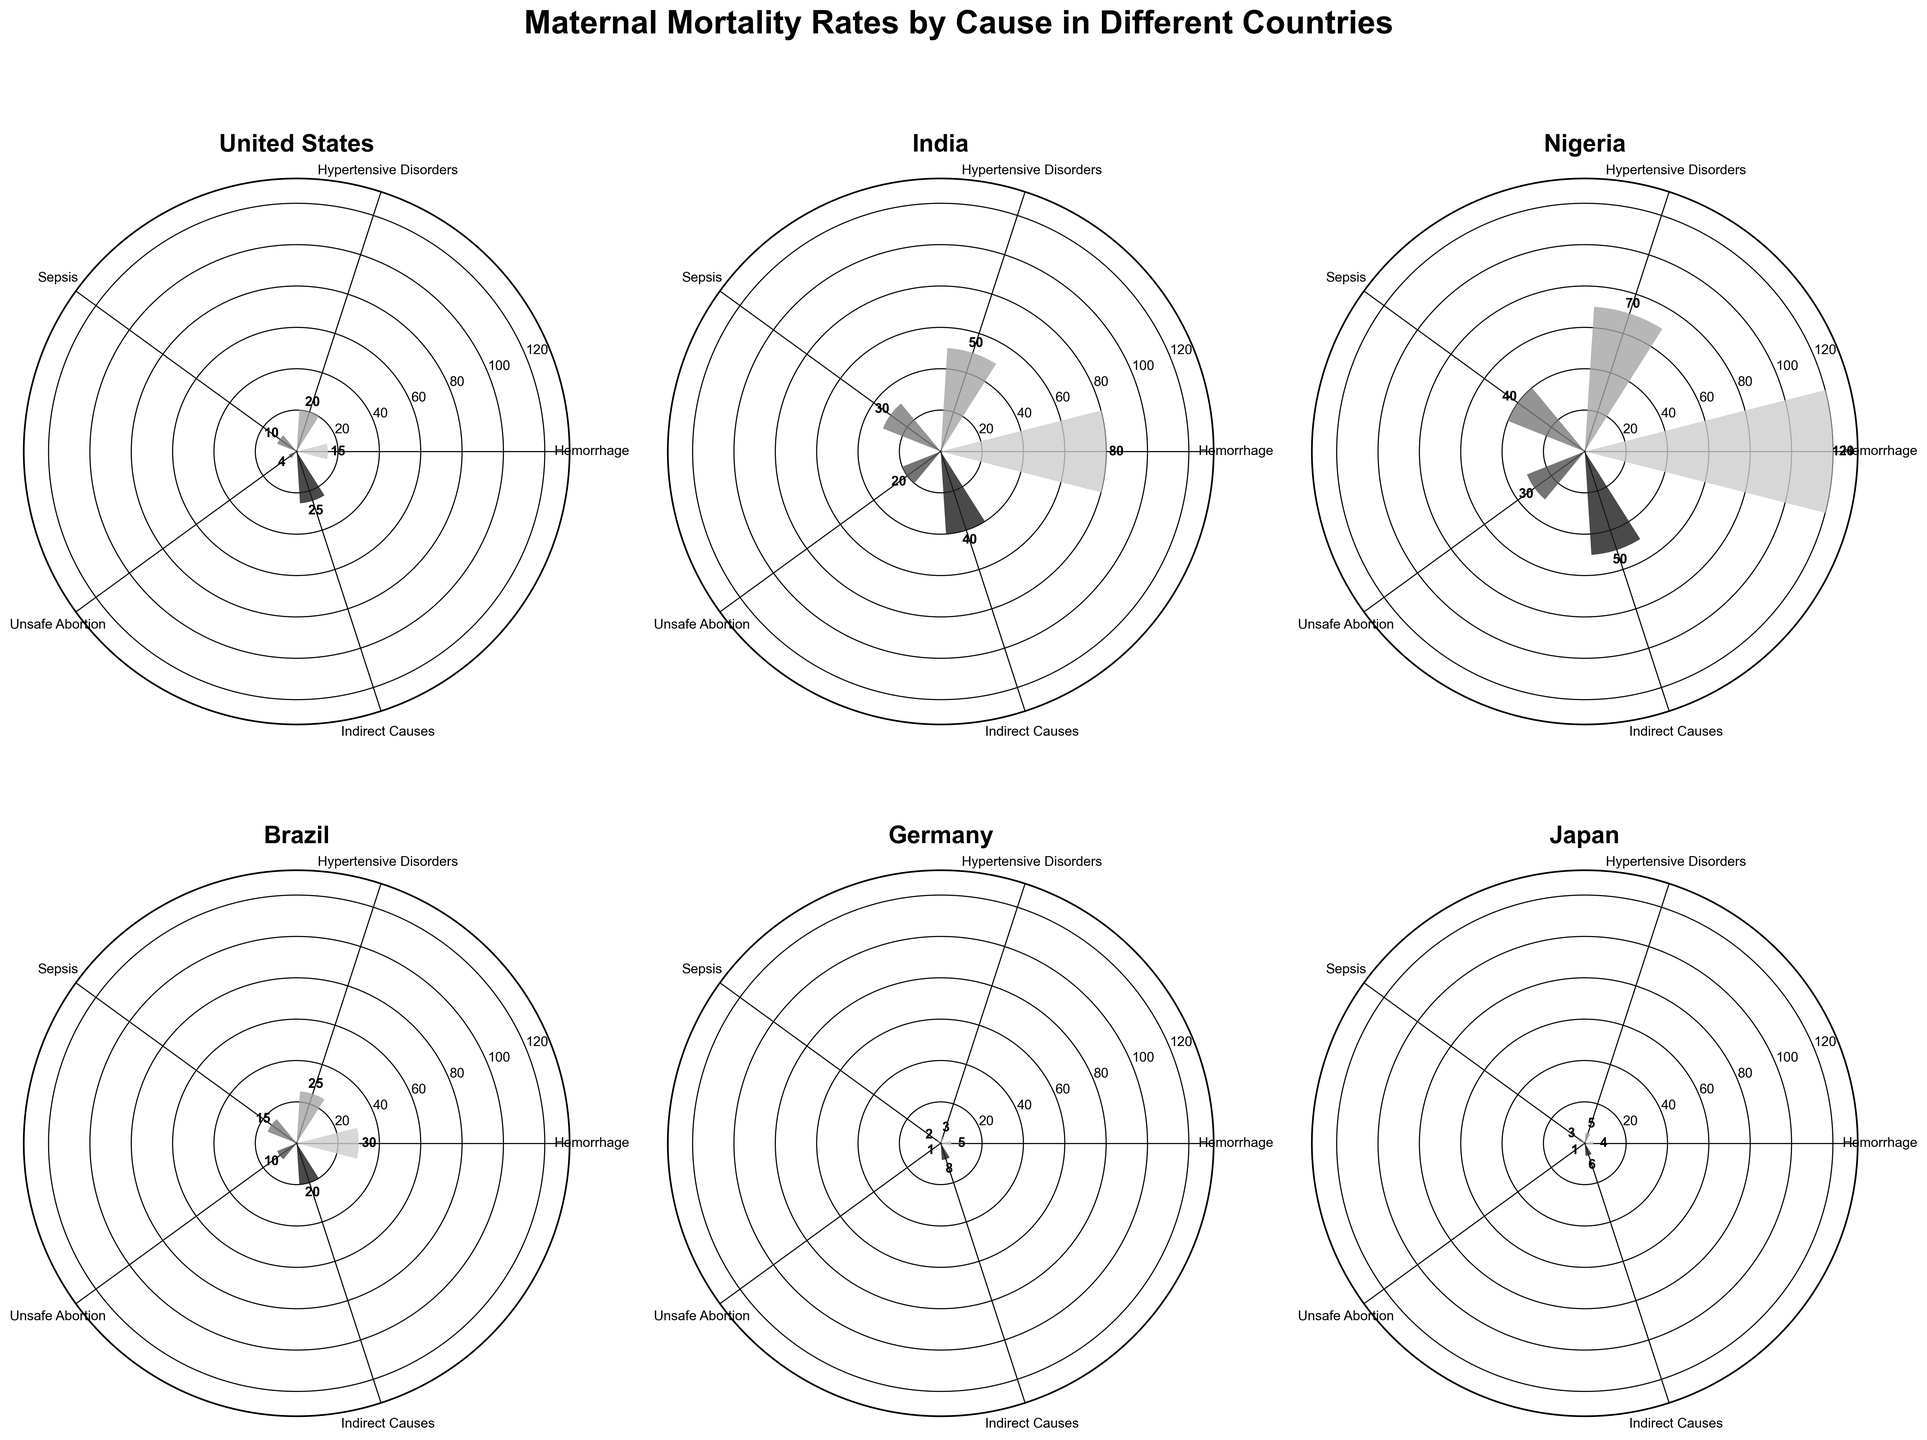What is the title of the chart? The title of a chart is usually placed at the top and describes the main topic. In this case, the title is "Maternal Mortality Rates by Cause in Different Countries".
Answer: Maternal Mortality Rates by Cause in Different Countries Which country has the highest maternal mortality rate for Hemorrhage? To determine this, we look at the bar representing Hemorrhage for each country and compare the values. The country with the largest bar is Nigeria with a rate of 120 per 100,000 live births.
Answer: Nigeria What is the maternal mortality rate for Sepsis in Germany? Locate the segment labeled "Sepsis" within the Germany plot and note the value indicated on the chart. The rate for Sepsis in Germany is 2 per 100,000 live births.
Answer: 2 Compare the maternal mortality rates for Unsafe Abortion between Brazil and the United States. Which country has a higher rate? Examine the bars representing Unsafe Abortion in both Brazil and the United States. Brazil has a rate of 10 per 100,000 live births, whereas the United States has a rate of 4 per 100,000 live births. Brazil has a higher rate.
Answer: Brazil How many different causes of maternal mortality are listed? Count the unique categories of causes in the chart. The causes are Hemorrhage, Hypertensive Disorders, Sepsis, Unsafe Abortion, and Indirect Causes, making a total of 5 different causes.
Answer: 5 What is the sum of maternal mortality rates for all causes in Japan? Locate the rates for each cause in Japan and sum them up: Hemorrhage (4), Hypertensive Disorders (5), Sepsis (3), Unsafe Abortion (1), and Indirect Causes (6). The sum is 4 + 5 + 3 + 1 + 6 = 19.
Answer: 19 How does the rate of Indirect Causes in India compare to that in Brazil? Find the values for Indirect Causes in both countries: India has a rate of 40 per 100,000 live births, while Brazil has a rate of 20 per 100,000 live births. India has a higher rate.
Answer: India What is the average maternal mortality rate for Hypertensive Disorders across the countries shown? Collect the rates for Hypertensive Disorders in each country: United States (20), India (50), Nigeria (70), Brazil (25), Germany (3), and Japan (5). The average is (20 + 50 + 70 + 25 + 3 + 5) / 6 = 173 / 6 ≈ 28.83.
Answer: 28.83 Which country has the lowest maternal mortality rate for any cause, and what is that rate? Identify the smallest bar in any plot. Germany has the lowest rate for Unsafe Abortion at 1 per 100,000 live births.
Answer: Germany, 1 